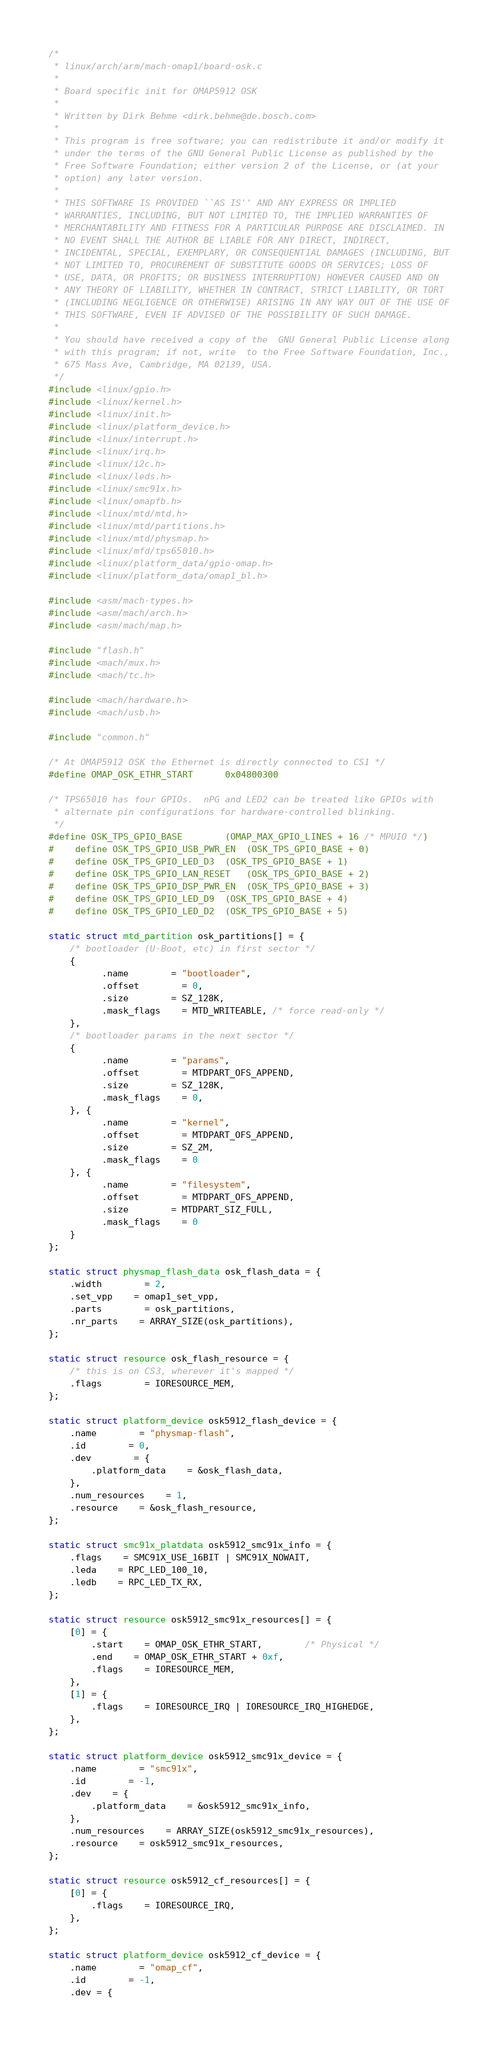Convert code to text. <code><loc_0><loc_0><loc_500><loc_500><_C_>/*
 * linux/arch/arm/mach-omap1/board-osk.c
 *
 * Board specific init for OMAP5912 OSK
 *
 * Written by Dirk Behme <dirk.behme@de.bosch.com>
 *
 * This program is free software; you can redistribute it and/or modify it
 * under the terms of the GNU General Public License as published by the
 * Free Software Foundation; either version 2 of the License, or (at your
 * option) any later version.
 *
 * THIS SOFTWARE IS PROVIDED ``AS IS'' AND ANY EXPRESS OR IMPLIED
 * WARRANTIES, INCLUDING, BUT NOT LIMITED TO, THE IMPLIED WARRANTIES OF
 * MERCHANTABILITY AND FITNESS FOR A PARTICULAR PURPOSE ARE DISCLAIMED. IN
 * NO EVENT SHALL THE AUTHOR BE LIABLE FOR ANY DIRECT, INDIRECT,
 * INCIDENTAL, SPECIAL, EXEMPLARY, OR CONSEQUENTIAL DAMAGES (INCLUDING, BUT
 * NOT LIMITED TO, PROCUREMENT OF SUBSTITUTE GOODS OR SERVICES; LOSS OF
 * USE, DATA, OR PROFITS; OR BUSINESS INTERRUPTION) HOWEVER CAUSED AND ON
 * ANY THEORY OF LIABILITY, WHETHER IN CONTRACT, STRICT LIABILITY, OR TORT
 * (INCLUDING NEGLIGENCE OR OTHERWISE) ARISING IN ANY WAY OUT OF THE USE OF
 * THIS SOFTWARE, EVEN IF ADVISED OF THE POSSIBILITY OF SUCH DAMAGE.
 *
 * You should have received a copy of the  GNU General Public License along
 * with this program; if not, write  to the Free Software Foundation, Inc.,
 * 675 Mass Ave, Cambridge, MA 02139, USA.
 */
#include <linux/gpio.h>
#include <linux/kernel.h>
#include <linux/init.h>
#include <linux/platform_device.h>
#include <linux/interrupt.h>
#include <linux/irq.h>
#include <linux/i2c.h>
#include <linux/leds.h>
#include <linux/smc91x.h>
#include <linux/omapfb.h>
#include <linux/mtd/mtd.h>
#include <linux/mtd/partitions.h>
#include <linux/mtd/physmap.h>
#include <linux/mfd/tps65010.h>
#include <linux/platform_data/gpio-omap.h>
#include <linux/platform_data/omap1_bl.h>

#include <asm/mach-types.h>
#include <asm/mach/arch.h>
#include <asm/mach/map.h>

#include "flash.h"
#include <mach/mux.h>
#include <mach/tc.h>

#include <mach/hardware.h>
#include <mach/usb.h>

#include "common.h"

/* At OMAP5912 OSK the Ethernet is directly connected to CS1 */
#define OMAP_OSK_ETHR_START		0x04800300

/* TPS65010 has four GPIOs.  nPG and LED2 can be treated like GPIOs with
 * alternate pin configurations for hardware-controlled blinking.
 */
#define OSK_TPS_GPIO_BASE		(OMAP_MAX_GPIO_LINES + 16 /* MPUIO */)
#	define OSK_TPS_GPIO_USB_PWR_EN	(OSK_TPS_GPIO_BASE + 0)
#	define OSK_TPS_GPIO_LED_D3	(OSK_TPS_GPIO_BASE + 1)
#	define OSK_TPS_GPIO_LAN_RESET	(OSK_TPS_GPIO_BASE + 2)
#	define OSK_TPS_GPIO_DSP_PWR_EN	(OSK_TPS_GPIO_BASE + 3)
#	define OSK_TPS_GPIO_LED_D9	(OSK_TPS_GPIO_BASE + 4)
#	define OSK_TPS_GPIO_LED_D2	(OSK_TPS_GPIO_BASE + 5)

static struct mtd_partition osk_partitions[] = {
	/* bootloader (U-Boot, etc) in first sector */
	{
	      .name		= "bootloader",
	      .offset		= 0,
	      .size		= SZ_128K,
	      .mask_flags	= MTD_WRITEABLE, /* force read-only */
	},
	/* bootloader params in the next sector */
	{
	      .name		= "params",
	      .offset		= MTDPART_OFS_APPEND,
	      .size		= SZ_128K,
	      .mask_flags	= 0,
	}, {
	      .name		= "kernel",
	      .offset		= MTDPART_OFS_APPEND,
	      .size		= SZ_2M,
	      .mask_flags	= 0
	}, {
	      .name		= "filesystem",
	      .offset		= MTDPART_OFS_APPEND,
	      .size		= MTDPART_SIZ_FULL,
	      .mask_flags	= 0
	}
};

static struct physmap_flash_data osk_flash_data = {
	.width		= 2,
	.set_vpp	= omap1_set_vpp,
	.parts		= osk_partitions,
	.nr_parts	= ARRAY_SIZE(osk_partitions),
};

static struct resource osk_flash_resource = {
	/* this is on CS3, wherever it's mapped */
	.flags		= IORESOURCE_MEM,
};

static struct platform_device osk5912_flash_device = {
	.name		= "physmap-flash",
	.id		= 0,
	.dev		= {
		.platform_data	= &osk_flash_data,
	},
	.num_resources	= 1,
	.resource	= &osk_flash_resource,
};

static struct smc91x_platdata osk5912_smc91x_info = {
	.flags	= SMC91X_USE_16BIT | SMC91X_NOWAIT,
	.leda	= RPC_LED_100_10,
	.ledb	= RPC_LED_TX_RX,
};

static struct resource osk5912_smc91x_resources[] = {
	[0] = {
		.start	= OMAP_OSK_ETHR_START,		/* Physical */
		.end	= OMAP_OSK_ETHR_START + 0xf,
		.flags	= IORESOURCE_MEM,
	},
	[1] = {
		.flags	= IORESOURCE_IRQ | IORESOURCE_IRQ_HIGHEDGE,
	},
};

static struct platform_device osk5912_smc91x_device = {
	.name		= "smc91x",
	.id		= -1,
	.dev	= {
		.platform_data	= &osk5912_smc91x_info,
	},
	.num_resources	= ARRAY_SIZE(osk5912_smc91x_resources),
	.resource	= osk5912_smc91x_resources,
};

static struct resource osk5912_cf_resources[] = {
	[0] = {
		.flags	= IORESOURCE_IRQ,
	},
};

static struct platform_device osk5912_cf_device = {
	.name		= "omap_cf",
	.id		= -1,
	.dev = {</code> 